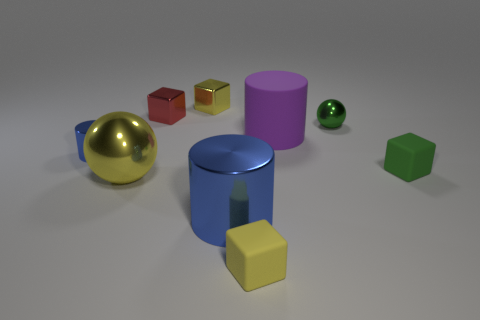Is the number of red things that are left of the big ball the same as the number of big green cylinders?
Ensure brevity in your answer.  Yes. Is the big cylinder that is in front of the purple thing made of the same material as the purple cylinder?
Offer a very short reply. No. Is the number of big cylinders behind the large sphere less than the number of small green objects?
Give a very brief answer. Yes. What number of metallic things are either gray cylinders or purple things?
Ensure brevity in your answer.  0. Is the tiny shiny cylinder the same color as the large metallic cylinder?
Make the answer very short. Yes. Is there any other thing of the same color as the big shiny ball?
Give a very brief answer. Yes. Does the matte thing on the right side of the big rubber thing have the same shape as the yellow thing behind the tiny red metallic cube?
Ensure brevity in your answer.  Yes. What number of things are either yellow metal objects or tiny metal things that are behind the small shiny ball?
Give a very brief answer. 3. How many other objects are there of the same size as the yellow metallic sphere?
Make the answer very short. 2. Are the blue cylinder to the right of the yellow ball and the ball in front of the purple rubber cylinder made of the same material?
Your answer should be compact. Yes. 